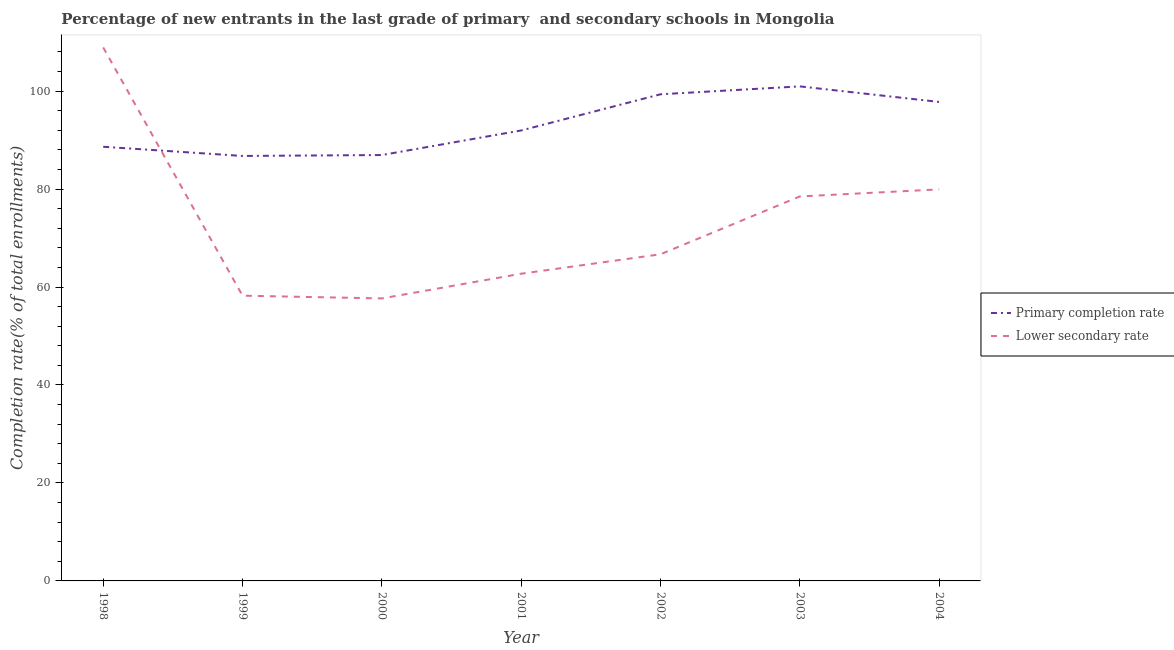What is the completion rate in secondary schools in 2003?
Your answer should be very brief. 78.49. Across all years, what is the maximum completion rate in secondary schools?
Keep it short and to the point. 108.92. Across all years, what is the minimum completion rate in primary schools?
Your answer should be very brief. 86.76. In which year was the completion rate in primary schools minimum?
Offer a very short reply. 1999. What is the total completion rate in primary schools in the graph?
Make the answer very short. 652.41. What is the difference between the completion rate in secondary schools in 1998 and that in 2003?
Your answer should be very brief. 30.42. What is the difference between the completion rate in secondary schools in 2004 and the completion rate in primary schools in 2003?
Your response must be concise. -21.03. What is the average completion rate in primary schools per year?
Your answer should be very brief. 93.2. In the year 1999, what is the difference between the completion rate in primary schools and completion rate in secondary schools?
Provide a short and direct response. 28.53. In how many years, is the completion rate in secondary schools greater than 8 %?
Make the answer very short. 7. What is the ratio of the completion rate in secondary schools in 1998 to that in 2001?
Ensure brevity in your answer.  1.74. What is the difference between the highest and the second highest completion rate in secondary schools?
Offer a terse response. 28.98. What is the difference between the highest and the lowest completion rate in secondary schools?
Keep it short and to the point. 51.24. Does the completion rate in secondary schools monotonically increase over the years?
Provide a succinct answer. No. Is the completion rate in secondary schools strictly greater than the completion rate in primary schools over the years?
Provide a short and direct response. No. Is the completion rate in primary schools strictly less than the completion rate in secondary schools over the years?
Offer a terse response. No. How many lines are there?
Your answer should be compact. 2. What is the difference between two consecutive major ticks on the Y-axis?
Your answer should be very brief. 20. Are the values on the major ticks of Y-axis written in scientific E-notation?
Provide a short and direct response. No. Does the graph contain grids?
Give a very brief answer. No. How many legend labels are there?
Keep it short and to the point. 2. What is the title of the graph?
Provide a short and direct response. Percentage of new entrants in the last grade of primary  and secondary schools in Mongolia. Does "State government" appear as one of the legend labels in the graph?
Keep it short and to the point. No. What is the label or title of the Y-axis?
Give a very brief answer. Completion rate(% of total enrollments). What is the Completion rate(% of total enrollments) in Primary completion rate in 1998?
Your answer should be very brief. 88.64. What is the Completion rate(% of total enrollments) of Lower secondary rate in 1998?
Your response must be concise. 108.92. What is the Completion rate(% of total enrollments) of Primary completion rate in 1999?
Give a very brief answer. 86.76. What is the Completion rate(% of total enrollments) in Lower secondary rate in 1999?
Your answer should be very brief. 58.24. What is the Completion rate(% of total enrollments) of Primary completion rate in 2000?
Your response must be concise. 86.95. What is the Completion rate(% of total enrollments) in Lower secondary rate in 2000?
Make the answer very short. 57.67. What is the Completion rate(% of total enrollments) in Primary completion rate in 2001?
Your response must be concise. 91.96. What is the Completion rate(% of total enrollments) of Lower secondary rate in 2001?
Offer a terse response. 62.72. What is the Completion rate(% of total enrollments) of Primary completion rate in 2002?
Keep it short and to the point. 99.35. What is the Completion rate(% of total enrollments) in Lower secondary rate in 2002?
Your answer should be very brief. 66.69. What is the Completion rate(% of total enrollments) of Primary completion rate in 2003?
Offer a very short reply. 100.96. What is the Completion rate(% of total enrollments) of Lower secondary rate in 2003?
Ensure brevity in your answer.  78.49. What is the Completion rate(% of total enrollments) of Primary completion rate in 2004?
Provide a short and direct response. 97.79. What is the Completion rate(% of total enrollments) of Lower secondary rate in 2004?
Provide a succinct answer. 79.94. Across all years, what is the maximum Completion rate(% of total enrollments) of Primary completion rate?
Offer a terse response. 100.96. Across all years, what is the maximum Completion rate(% of total enrollments) in Lower secondary rate?
Your answer should be compact. 108.92. Across all years, what is the minimum Completion rate(% of total enrollments) in Primary completion rate?
Keep it short and to the point. 86.76. Across all years, what is the minimum Completion rate(% of total enrollments) in Lower secondary rate?
Keep it short and to the point. 57.67. What is the total Completion rate(% of total enrollments) of Primary completion rate in the graph?
Offer a very short reply. 652.41. What is the total Completion rate(% of total enrollments) in Lower secondary rate in the graph?
Give a very brief answer. 512.66. What is the difference between the Completion rate(% of total enrollments) in Primary completion rate in 1998 and that in 1999?
Provide a succinct answer. 1.88. What is the difference between the Completion rate(% of total enrollments) of Lower secondary rate in 1998 and that in 1999?
Your response must be concise. 50.68. What is the difference between the Completion rate(% of total enrollments) in Primary completion rate in 1998 and that in 2000?
Provide a succinct answer. 1.69. What is the difference between the Completion rate(% of total enrollments) of Lower secondary rate in 1998 and that in 2000?
Offer a terse response. 51.24. What is the difference between the Completion rate(% of total enrollments) in Primary completion rate in 1998 and that in 2001?
Provide a succinct answer. -3.32. What is the difference between the Completion rate(% of total enrollments) in Lower secondary rate in 1998 and that in 2001?
Give a very brief answer. 46.2. What is the difference between the Completion rate(% of total enrollments) of Primary completion rate in 1998 and that in 2002?
Offer a terse response. -10.71. What is the difference between the Completion rate(% of total enrollments) of Lower secondary rate in 1998 and that in 2002?
Offer a very short reply. 42.23. What is the difference between the Completion rate(% of total enrollments) in Primary completion rate in 1998 and that in 2003?
Make the answer very short. -12.33. What is the difference between the Completion rate(% of total enrollments) of Lower secondary rate in 1998 and that in 2003?
Offer a very short reply. 30.42. What is the difference between the Completion rate(% of total enrollments) in Primary completion rate in 1998 and that in 2004?
Make the answer very short. -9.15. What is the difference between the Completion rate(% of total enrollments) in Lower secondary rate in 1998 and that in 2004?
Your answer should be compact. 28.98. What is the difference between the Completion rate(% of total enrollments) of Primary completion rate in 1999 and that in 2000?
Provide a succinct answer. -0.19. What is the difference between the Completion rate(% of total enrollments) in Lower secondary rate in 1999 and that in 2000?
Keep it short and to the point. 0.56. What is the difference between the Completion rate(% of total enrollments) of Primary completion rate in 1999 and that in 2001?
Ensure brevity in your answer.  -5.2. What is the difference between the Completion rate(% of total enrollments) in Lower secondary rate in 1999 and that in 2001?
Offer a very short reply. -4.48. What is the difference between the Completion rate(% of total enrollments) of Primary completion rate in 1999 and that in 2002?
Your answer should be very brief. -12.59. What is the difference between the Completion rate(% of total enrollments) of Lower secondary rate in 1999 and that in 2002?
Offer a terse response. -8.45. What is the difference between the Completion rate(% of total enrollments) of Primary completion rate in 1999 and that in 2003?
Your answer should be compact. -14.2. What is the difference between the Completion rate(% of total enrollments) in Lower secondary rate in 1999 and that in 2003?
Ensure brevity in your answer.  -20.26. What is the difference between the Completion rate(% of total enrollments) of Primary completion rate in 1999 and that in 2004?
Your answer should be compact. -11.02. What is the difference between the Completion rate(% of total enrollments) in Lower secondary rate in 1999 and that in 2004?
Give a very brief answer. -21.7. What is the difference between the Completion rate(% of total enrollments) of Primary completion rate in 2000 and that in 2001?
Keep it short and to the point. -5.01. What is the difference between the Completion rate(% of total enrollments) in Lower secondary rate in 2000 and that in 2001?
Your answer should be compact. -5.05. What is the difference between the Completion rate(% of total enrollments) of Primary completion rate in 2000 and that in 2002?
Provide a succinct answer. -12.4. What is the difference between the Completion rate(% of total enrollments) of Lower secondary rate in 2000 and that in 2002?
Provide a short and direct response. -9.02. What is the difference between the Completion rate(% of total enrollments) in Primary completion rate in 2000 and that in 2003?
Keep it short and to the point. -14.02. What is the difference between the Completion rate(% of total enrollments) in Lower secondary rate in 2000 and that in 2003?
Make the answer very short. -20.82. What is the difference between the Completion rate(% of total enrollments) of Primary completion rate in 2000 and that in 2004?
Keep it short and to the point. -10.84. What is the difference between the Completion rate(% of total enrollments) in Lower secondary rate in 2000 and that in 2004?
Ensure brevity in your answer.  -22.26. What is the difference between the Completion rate(% of total enrollments) in Primary completion rate in 2001 and that in 2002?
Give a very brief answer. -7.39. What is the difference between the Completion rate(% of total enrollments) in Lower secondary rate in 2001 and that in 2002?
Your response must be concise. -3.97. What is the difference between the Completion rate(% of total enrollments) in Primary completion rate in 2001 and that in 2003?
Offer a very short reply. -9. What is the difference between the Completion rate(% of total enrollments) of Lower secondary rate in 2001 and that in 2003?
Make the answer very short. -15.77. What is the difference between the Completion rate(% of total enrollments) in Primary completion rate in 2001 and that in 2004?
Your answer should be compact. -5.82. What is the difference between the Completion rate(% of total enrollments) of Lower secondary rate in 2001 and that in 2004?
Keep it short and to the point. -17.22. What is the difference between the Completion rate(% of total enrollments) in Primary completion rate in 2002 and that in 2003?
Your answer should be very brief. -1.61. What is the difference between the Completion rate(% of total enrollments) in Lower secondary rate in 2002 and that in 2003?
Give a very brief answer. -11.8. What is the difference between the Completion rate(% of total enrollments) of Primary completion rate in 2002 and that in 2004?
Your answer should be very brief. 1.56. What is the difference between the Completion rate(% of total enrollments) in Lower secondary rate in 2002 and that in 2004?
Make the answer very short. -13.25. What is the difference between the Completion rate(% of total enrollments) of Primary completion rate in 2003 and that in 2004?
Provide a short and direct response. 3.18. What is the difference between the Completion rate(% of total enrollments) in Lower secondary rate in 2003 and that in 2004?
Keep it short and to the point. -1.44. What is the difference between the Completion rate(% of total enrollments) in Primary completion rate in 1998 and the Completion rate(% of total enrollments) in Lower secondary rate in 1999?
Your response must be concise. 30.4. What is the difference between the Completion rate(% of total enrollments) of Primary completion rate in 1998 and the Completion rate(% of total enrollments) of Lower secondary rate in 2000?
Ensure brevity in your answer.  30.96. What is the difference between the Completion rate(% of total enrollments) of Primary completion rate in 1998 and the Completion rate(% of total enrollments) of Lower secondary rate in 2001?
Offer a terse response. 25.92. What is the difference between the Completion rate(% of total enrollments) of Primary completion rate in 1998 and the Completion rate(% of total enrollments) of Lower secondary rate in 2002?
Make the answer very short. 21.95. What is the difference between the Completion rate(% of total enrollments) in Primary completion rate in 1998 and the Completion rate(% of total enrollments) in Lower secondary rate in 2003?
Offer a very short reply. 10.14. What is the difference between the Completion rate(% of total enrollments) in Primary completion rate in 1998 and the Completion rate(% of total enrollments) in Lower secondary rate in 2004?
Keep it short and to the point. 8.7. What is the difference between the Completion rate(% of total enrollments) in Primary completion rate in 1999 and the Completion rate(% of total enrollments) in Lower secondary rate in 2000?
Your answer should be compact. 29.09. What is the difference between the Completion rate(% of total enrollments) in Primary completion rate in 1999 and the Completion rate(% of total enrollments) in Lower secondary rate in 2001?
Provide a short and direct response. 24.04. What is the difference between the Completion rate(% of total enrollments) of Primary completion rate in 1999 and the Completion rate(% of total enrollments) of Lower secondary rate in 2002?
Your answer should be very brief. 20.07. What is the difference between the Completion rate(% of total enrollments) in Primary completion rate in 1999 and the Completion rate(% of total enrollments) in Lower secondary rate in 2003?
Ensure brevity in your answer.  8.27. What is the difference between the Completion rate(% of total enrollments) in Primary completion rate in 1999 and the Completion rate(% of total enrollments) in Lower secondary rate in 2004?
Ensure brevity in your answer.  6.83. What is the difference between the Completion rate(% of total enrollments) in Primary completion rate in 2000 and the Completion rate(% of total enrollments) in Lower secondary rate in 2001?
Make the answer very short. 24.23. What is the difference between the Completion rate(% of total enrollments) of Primary completion rate in 2000 and the Completion rate(% of total enrollments) of Lower secondary rate in 2002?
Your answer should be compact. 20.26. What is the difference between the Completion rate(% of total enrollments) of Primary completion rate in 2000 and the Completion rate(% of total enrollments) of Lower secondary rate in 2003?
Offer a terse response. 8.45. What is the difference between the Completion rate(% of total enrollments) in Primary completion rate in 2000 and the Completion rate(% of total enrollments) in Lower secondary rate in 2004?
Offer a very short reply. 7.01. What is the difference between the Completion rate(% of total enrollments) of Primary completion rate in 2001 and the Completion rate(% of total enrollments) of Lower secondary rate in 2002?
Provide a succinct answer. 25.27. What is the difference between the Completion rate(% of total enrollments) in Primary completion rate in 2001 and the Completion rate(% of total enrollments) in Lower secondary rate in 2003?
Keep it short and to the point. 13.47. What is the difference between the Completion rate(% of total enrollments) in Primary completion rate in 2001 and the Completion rate(% of total enrollments) in Lower secondary rate in 2004?
Make the answer very short. 12.03. What is the difference between the Completion rate(% of total enrollments) of Primary completion rate in 2002 and the Completion rate(% of total enrollments) of Lower secondary rate in 2003?
Offer a very short reply. 20.86. What is the difference between the Completion rate(% of total enrollments) in Primary completion rate in 2002 and the Completion rate(% of total enrollments) in Lower secondary rate in 2004?
Your answer should be very brief. 19.41. What is the difference between the Completion rate(% of total enrollments) of Primary completion rate in 2003 and the Completion rate(% of total enrollments) of Lower secondary rate in 2004?
Provide a succinct answer. 21.03. What is the average Completion rate(% of total enrollments) of Primary completion rate per year?
Keep it short and to the point. 93.2. What is the average Completion rate(% of total enrollments) of Lower secondary rate per year?
Provide a short and direct response. 73.24. In the year 1998, what is the difference between the Completion rate(% of total enrollments) in Primary completion rate and Completion rate(% of total enrollments) in Lower secondary rate?
Your answer should be compact. -20.28. In the year 1999, what is the difference between the Completion rate(% of total enrollments) of Primary completion rate and Completion rate(% of total enrollments) of Lower secondary rate?
Provide a succinct answer. 28.53. In the year 2000, what is the difference between the Completion rate(% of total enrollments) of Primary completion rate and Completion rate(% of total enrollments) of Lower secondary rate?
Your response must be concise. 29.27. In the year 2001, what is the difference between the Completion rate(% of total enrollments) in Primary completion rate and Completion rate(% of total enrollments) in Lower secondary rate?
Keep it short and to the point. 29.24. In the year 2002, what is the difference between the Completion rate(% of total enrollments) of Primary completion rate and Completion rate(% of total enrollments) of Lower secondary rate?
Make the answer very short. 32.66. In the year 2003, what is the difference between the Completion rate(% of total enrollments) of Primary completion rate and Completion rate(% of total enrollments) of Lower secondary rate?
Give a very brief answer. 22.47. In the year 2004, what is the difference between the Completion rate(% of total enrollments) in Primary completion rate and Completion rate(% of total enrollments) in Lower secondary rate?
Keep it short and to the point. 17.85. What is the ratio of the Completion rate(% of total enrollments) in Primary completion rate in 1998 to that in 1999?
Give a very brief answer. 1.02. What is the ratio of the Completion rate(% of total enrollments) in Lower secondary rate in 1998 to that in 1999?
Ensure brevity in your answer.  1.87. What is the ratio of the Completion rate(% of total enrollments) in Primary completion rate in 1998 to that in 2000?
Keep it short and to the point. 1.02. What is the ratio of the Completion rate(% of total enrollments) of Lower secondary rate in 1998 to that in 2000?
Your answer should be very brief. 1.89. What is the ratio of the Completion rate(% of total enrollments) in Primary completion rate in 1998 to that in 2001?
Offer a terse response. 0.96. What is the ratio of the Completion rate(% of total enrollments) in Lower secondary rate in 1998 to that in 2001?
Offer a very short reply. 1.74. What is the ratio of the Completion rate(% of total enrollments) in Primary completion rate in 1998 to that in 2002?
Ensure brevity in your answer.  0.89. What is the ratio of the Completion rate(% of total enrollments) of Lower secondary rate in 1998 to that in 2002?
Provide a succinct answer. 1.63. What is the ratio of the Completion rate(% of total enrollments) in Primary completion rate in 1998 to that in 2003?
Keep it short and to the point. 0.88. What is the ratio of the Completion rate(% of total enrollments) of Lower secondary rate in 1998 to that in 2003?
Provide a succinct answer. 1.39. What is the ratio of the Completion rate(% of total enrollments) of Primary completion rate in 1998 to that in 2004?
Your response must be concise. 0.91. What is the ratio of the Completion rate(% of total enrollments) in Lower secondary rate in 1998 to that in 2004?
Offer a terse response. 1.36. What is the ratio of the Completion rate(% of total enrollments) in Primary completion rate in 1999 to that in 2000?
Ensure brevity in your answer.  1. What is the ratio of the Completion rate(% of total enrollments) in Lower secondary rate in 1999 to that in 2000?
Offer a very short reply. 1.01. What is the ratio of the Completion rate(% of total enrollments) in Primary completion rate in 1999 to that in 2001?
Provide a short and direct response. 0.94. What is the ratio of the Completion rate(% of total enrollments) in Lower secondary rate in 1999 to that in 2001?
Offer a terse response. 0.93. What is the ratio of the Completion rate(% of total enrollments) of Primary completion rate in 1999 to that in 2002?
Make the answer very short. 0.87. What is the ratio of the Completion rate(% of total enrollments) in Lower secondary rate in 1999 to that in 2002?
Your answer should be very brief. 0.87. What is the ratio of the Completion rate(% of total enrollments) in Primary completion rate in 1999 to that in 2003?
Provide a short and direct response. 0.86. What is the ratio of the Completion rate(% of total enrollments) of Lower secondary rate in 1999 to that in 2003?
Offer a very short reply. 0.74. What is the ratio of the Completion rate(% of total enrollments) of Primary completion rate in 1999 to that in 2004?
Give a very brief answer. 0.89. What is the ratio of the Completion rate(% of total enrollments) in Lower secondary rate in 1999 to that in 2004?
Your answer should be compact. 0.73. What is the ratio of the Completion rate(% of total enrollments) of Primary completion rate in 2000 to that in 2001?
Provide a succinct answer. 0.95. What is the ratio of the Completion rate(% of total enrollments) in Lower secondary rate in 2000 to that in 2001?
Your answer should be compact. 0.92. What is the ratio of the Completion rate(% of total enrollments) of Primary completion rate in 2000 to that in 2002?
Give a very brief answer. 0.88. What is the ratio of the Completion rate(% of total enrollments) of Lower secondary rate in 2000 to that in 2002?
Provide a succinct answer. 0.86. What is the ratio of the Completion rate(% of total enrollments) of Primary completion rate in 2000 to that in 2003?
Offer a terse response. 0.86. What is the ratio of the Completion rate(% of total enrollments) of Lower secondary rate in 2000 to that in 2003?
Provide a succinct answer. 0.73. What is the ratio of the Completion rate(% of total enrollments) of Primary completion rate in 2000 to that in 2004?
Your answer should be compact. 0.89. What is the ratio of the Completion rate(% of total enrollments) in Lower secondary rate in 2000 to that in 2004?
Your answer should be very brief. 0.72. What is the ratio of the Completion rate(% of total enrollments) of Primary completion rate in 2001 to that in 2002?
Offer a very short reply. 0.93. What is the ratio of the Completion rate(% of total enrollments) in Lower secondary rate in 2001 to that in 2002?
Provide a succinct answer. 0.94. What is the ratio of the Completion rate(% of total enrollments) in Primary completion rate in 2001 to that in 2003?
Your response must be concise. 0.91. What is the ratio of the Completion rate(% of total enrollments) of Lower secondary rate in 2001 to that in 2003?
Your response must be concise. 0.8. What is the ratio of the Completion rate(% of total enrollments) in Primary completion rate in 2001 to that in 2004?
Provide a succinct answer. 0.94. What is the ratio of the Completion rate(% of total enrollments) in Lower secondary rate in 2001 to that in 2004?
Offer a terse response. 0.78. What is the ratio of the Completion rate(% of total enrollments) in Primary completion rate in 2002 to that in 2003?
Your answer should be very brief. 0.98. What is the ratio of the Completion rate(% of total enrollments) of Lower secondary rate in 2002 to that in 2003?
Offer a very short reply. 0.85. What is the ratio of the Completion rate(% of total enrollments) of Lower secondary rate in 2002 to that in 2004?
Offer a very short reply. 0.83. What is the ratio of the Completion rate(% of total enrollments) in Primary completion rate in 2003 to that in 2004?
Provide a short and direct response. 1.03. What is the ratio of the Completion rate(% of total enrollments) of Lower secondary rate in 2003 to that in 2004?
Your answer should be compact. 0.98. What is the difference between the highest and the second highest Completion rate(% of total enrollments) of Primary completion rate?
Ensure brevity in your answer.  1.61. What is the difference between the highest and the second highest Completion rate(% of total enrollments) in Lower secondary rate?
Offer a terse response. 28.98. What is the difference between the highest and the lowest Completion rate(% of total enrollments) of Primary completion rate?
Your answer should be compact. 14.2. What is the difference between the highest and the lowest Completion rate(% of total enrollments) in Lower secondary rate?
Make the answer very short. 51.24. 